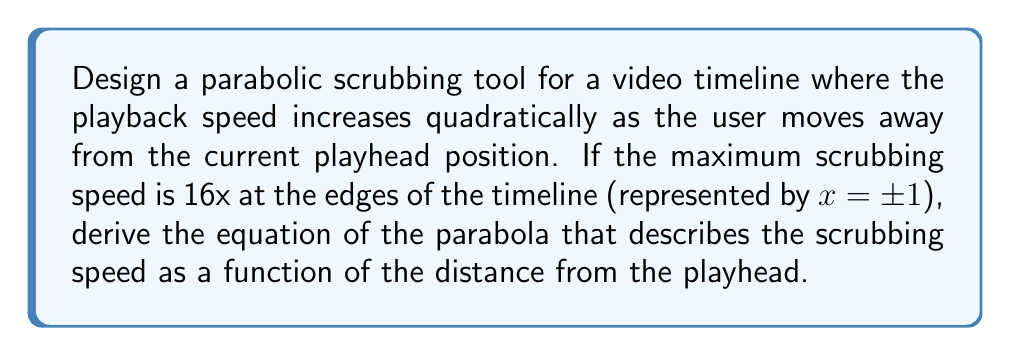Give your solution to this math problem. Let's approach this step-by-step:

1) We know that a parabola has the general form:
   $$y = ax^2 + bx + c$$

2) Given the information:
   - The parabola is symmetric around the y-axis (playhead position)
   - At x = 0 (playhead position), the speed should be 1x (normal playback)
   - At x = ±1 (edges of timeline), the speed should be 16x

3) Due to symmetry, there's no linear term, so b = 0. Our equation becomes:
   $$y = ax^2 + c$$

4) At the playhead (x = 0), speed is 1x:
   $$1 = a(0)^2 + c$$
   $$1 = c$$

5) At the edges (x = ±1), speed is 16x:
   $$16 = a(1)^2 + 1$$
   $$16 = a + 1$$
   $$15 = a$$

6) Substituting these values into our equation:
   $$y = 15x^2 + 1$$

7) This gives us the scrubbing speed (y) as a function of distance from the playhead (x).

8) To make it more intuitive for users, we can express it in terms of the scrubbing speed multiplier:
   $$\text{Speed Multiplier} = 15x^2 + 1$$

Where x is the normalized distance from the playhead (-1 ≤ x ≤ 1).
Answer: $$y = 15x^2 + 1$$ 